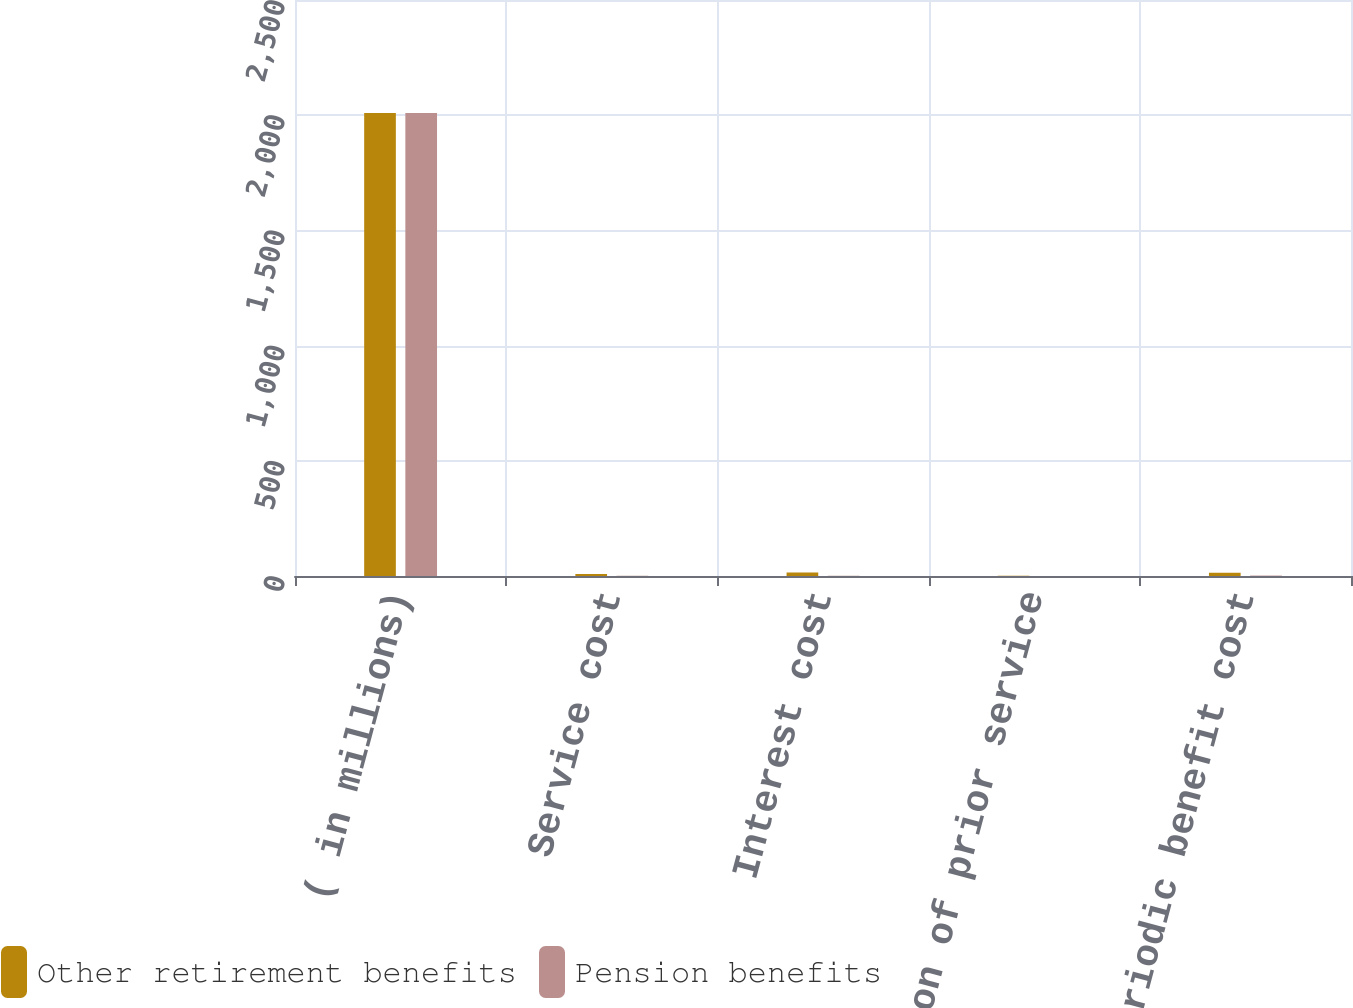Convert chart. <chart><loc_0><loc_0><loc_500><loc_500><stacked_bar_chart><ecel><fcel>( in millions)<fcel>Service cost<fcel>Interest cost<fcel>Amortization of prior service<fcel>Net periodic benefit cost<nl><fcel>Other retirement benefits<fcel>2010<fcel>8.6<fcel>15.7<fcel>1.1<fcel>14.2<nl><fcel>Pension benefits<fcel>2010<fcel>1.1<fcel>0.8<fcel>0.1<fcel>1.9<nl></chart> 